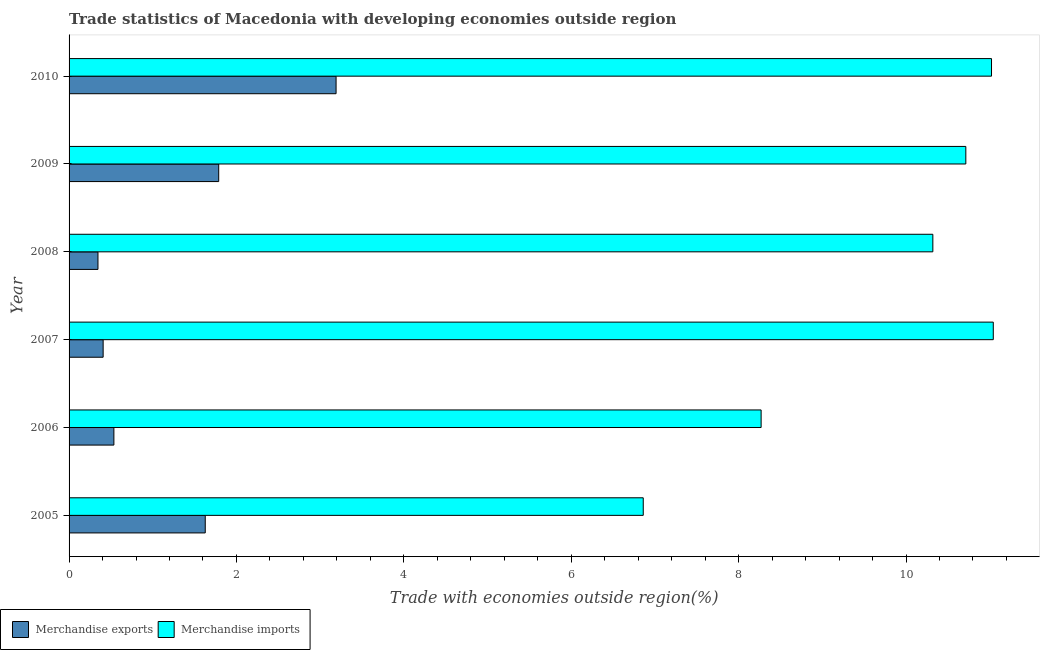How many different coloured bars are there?
Give a very brief answer. 2. How many groups of bars are there?
Your answer should be compact. 6. How many bars are there on the 5th tick from the top?
Ensure brevity in your answer.  2. What is the label of the 2nd group of bars from the top?
Offer a very short reply. 2009. What is the merchandise exports in 2007?
Your answer should be compact. 0.41. Across all years, what is the maximum merchandise imports?
Make the answer very short. 11.04. Across all years, what is the minimum merchandise imports?
Provide a short and direct response. 6.86. In which year was the merchandise imports maximum?
Provide a short and direct response. 2007. In which year was the merchandise exports minimum?
Your answer should be compact. 2008. What is the total merchandise imports in the graph?
Your response must be concise. 58.23. What is the difference between the merchandise imports in 2006 and that in 2008?
Your answer should be very brief. -2.05. What is the difference between the merchandise exports in 2008 and the merchandise imports in 2010?
Make the answer very short. -10.68. What is the average merchandise exports per year?
Ensure brevity in your answer.  1.31. In the year 2005, what is the difference between the merchandise exports and merchandise imports?
Make the answer very short. -5.23. In how many years, is the merchandise imports greater than 10.4 %?
Give a very brief answer. 3. Is the difference between the merchandise exports in 2009 and 2010 greater than the difference between the merchandise imports in 2009 and 2010?
Offer a very short reply. No. What is the difference between the highest and the second highest merchandise imports?
Keep it short and to the point. 0.02. What is the difference between the highest and the lowest merchandise exports?
Your answer should be very brief. 2.84. What does the 2nd bar from the top in 2005 represents?
Your response must be concise. Merchandise exports. How many years are there in the graph?
Make the answer very short. 6. Are the values on the major ticks of X-axis written in scientific E-notation?
Provide a short and direct response. No. Does the graph contain any zero values?
Offer a very short reply. No. Does the graph contain grids?
Keep it short and to the point. No. Where does the legend appear in the graph?
Provide a succinct answer. Bottom left. How many legend labels are there?
Your response must be concise. 2. How are the legend labels stacked?
Ensure brevity in your answer.  Horizontal. What is the title of the graph?
Give a very brief answer. Trade statistics of Macedonia with developing economies outside region. What is the label or title of the X-axis?
Your response must be concise. Trade with economies outside region(%). What is the Trade with economies outside region(%) in Merchandise exports in 2005?
Make the answer very short. 1.63. What is the Trade with economies outside region(%) of Merchandise imports in 2005?
Provide a succinct answer. 6.86. What is the Trade with economies outside region(%) of Merchandise exports in 2006?
Your response must be concise. 0.54. What is the Trade with economies outside region(%) of Merchandise imports in 2006?
Ensure brevity in your answer.  8.27. What is the Trade with economies outside region(%) of Merchandise exports in 2007?
Your answer should be very brief. 0.41. What is the Trade with economies outside region(%) in Merchandise imports in 2007?
Your answer should be very brief. 11.04. What is the Trade with economies outside region(%) of Merchandise exports in 2008?
Provide a succinct answer. 0.35. What is the Trade with economies outside region(%) in Merchandise imports in 2008?
Give a very brief answer. 10.32. What is the Trade with economies outside region(%) of Merchandise exports in 2009?
Offer a terse response. 1.79. What is the Trade with economies outside region(%) in Merchandise imports in 2009?
Your answer should be very brief. 10.71. What is the Trade with economies outside region(%) in Merchandise exports in 2010?
Your response must be concise. 3.19. What is the Trade with economies outside region(%) of Merchandise imports in 2010?
Give a very brief answer. 11.02. Across all years, what is the maximum Trade with economies outside region(%) in Merchandise exports?
Ensure brevity in your answer.  3.19. Across all years, what is the maximum Trade with economies outside region(%) in Merchandise imports?
Your response must be concise. 11.04. Across all years, what is the minimum Trade with economies outside region(%) in Merchandise exports?
Offer a very short reply. 0.35. Across all years, what is the minimum Trade with economies outside region(%) of Merchandise imports?
Offer a terse response. 6.86. What is the total Trade with economies outside region(%) in Merchandise exports in the graph?
Provide a succinct answer. 7.89. What is the total Trade with economies outside region(%) in Merchandise imports in the graph?
Provide a short and direct response. 58.23. What is the difference between the Trade with economies outside region(%) in Merchandise exports in 2005 and that in 2006?
Make the answer very short. 1.09. What is the difference between the Trade with economies outside region(%) of Merchandise imports in 2005 and that in 2006?
Make the answer very short. -1.41. What is the difference between the Trade with economies outside region(%) in Merchandise exports in 2005 and that in 2007?
Provide a short and direct response. 1.22. What is the difference between the Trade with economies outside region(%) in Merchandise imports in 2005 and that in 2007?
Make the answer very short. -4.18. What is the difference between the Trade with economies outside region(%) in Merchandise exports in 2005 and that in 2008?
Offer a terse response. 1.28. What is the difference between the Trade with economies outside region(%) of Merchandise imports in 2005 and that in 2008?
Provide a short and direct response. -3.46. What is the difference between the Trade with economies outside region(%) in Merchandise exports in 2005 and that in 2009?
Offer a terse response. -0.16. What is the difference between the Trade with economies outside region(%) in Merchandise imports in 2005 and that in 2009?
Offer a terse response. -3.85. What is the difference between the Trade with economies outside region(%) of Merchandise exports in 2005 and that in 2010?
Your answer should be very brief. -1.56. What is the difference between the Trade with economies outside region(%) in Merchandise imports in 2005 and that in 2010?
Keep it short and to the point. -4.16. What is the difference between the Trade with economies outside region(%) in Merchandise exports in 2006 and that in 2007?
Give a very brief answer. 0.13. What is the difference between the Trade with economies outside region(%) in Merchandise imports in 2006 and that in 2007?
Make the answer very short. -2.77. What is the difference between the Trade with economies outside region(%) of Merchandise exports in 2006 and that in 2008?
Ensure brevity in your answer.  0.19. What is the difference between the Trade with economies outside region(%) of Merchandise imports in 2006 and that in 2008?
Keep it short and to the point. -2.05. What is the difference between the Trade with economies outside region(%) in Merchandise exports in 2006 and that in 2009?
Your answer should be compact. -1.25. What is the difference between the Trade with economies outside region(%) in Merchandise imports in 2006 and that in 2009?
Offer a terse response. -2.45. What is the difference between the Trade with economies outside region(%) of Merchandise exports in 2006 and that in 2010?
Your response must be concise. -2.65. What is the difference between the Trade with economies outside region(%) in Merchandise imports in 2006 and that in 2010?
Offer a terse response. -2.75. What is the difference between the Trade with economies outside region(%) of Merchandise exports in 2007 and that in 2008?
Provide a succinct answer. 0.06. What is the difference between the Trade with economies outside region(%) in Merchandise imports in 2007 and that in 2008?
Your answer should be very brief. 0.72. What is the difference between the Trade with economies outside region(%) of Merchandise exports in 2007 and that in 2009?
Provide a short and direct response. -1.38. What is the difference between the Trade with economies outside region(%) of Merchandise imports in 2007 and that in 2009?
Give a very brief answer. 0.33. What is the difference between the Trade with economies outside region(%) in Merchandise exports in 2007 and that in 2010?
Offer a terse response. -2.78. What is the difference between the Trade with economies outside region(%) of Merchandise imports in 2007 and that in 2010?
Make the answer very short. 0.02. What is the difference between the Trade with economies outside region(%) of Merchandise exports in 2008 and that in 2009?
Your response must be concise. -1.44. What is the difference between the Trade with economies outside region(%) of Merchandise imports in 2008 and that in 2009?
Ensure brevity in your answer.  -0.39. What is the difference between the Trade with economies outside region(%) in Merchandise exports in 2008 and that in 2010?
Keep it short and to the point. -2.84. What is the difference between the Trade with economies outside region(%) in Merchandise imports in 2008 and that in 2010?
Give a very brief answer. -0.7. What is the difference between the Trade with economies outside region(%) in Merchandise exports in 2009 and that in 2010?
Offer a terse response. -1.4. What is the difference between the Trade with economies outside region(%) in Merchandise imports in 2009 and that in 2010?
Your response must be concise. -0.31. What is the difference between the Trade with economies outside region(%) of Merchandise exports in 2005 and the Trade with economies outside region(%) of Merchandise imports in 2006?
Your answer should be very brief. -6.64. What is the difference between the Trade with economies outside region(%) in Merchandise exports in 2005 and the Trade with economies outside region(%) in Merchandise imports in 2007?
Keep it short and to the point. -9.42. What is the difference between the Trade with economies outside region(%) in Merchandise exports in 2005 and the Trade with economies outside region(%) in Merchandise imports in 2008?
Offer a terse response. -8.69. What is the difference between the Trade with economies outside region(%) of Merchandise exports in 2005 and the Trade with economies outside region(%) of Merchandise imports in 2009?
Provide a succinct answer. -9.09. What is the difference between the Trade with economies outside region(%) in Merchandise exports in 2005 and the Trade with economies outside region(%) in Merchandise imports in 2010?
Make the answer very short. -9.39. What is the difference between the Trade with economies outside region(%) of Merchandise exports in 2006 and the Trade with economies outside region(%) of Merchandise imports in 2007?
Give a very brief answer. -10.51. What is the difference between the Trade with economies outside region(%) in Merchandise exports in 2006 and the Trade with economies outside region(%) in Merchandise imports in 2008?
Provide a short and direct response. -9.79. What is the difference between the Trade with economies outside region(%) in Merchandise exports in 2006 and the Trade with economies outside region(%) in Merchandise imports in 2009?
Provide a short and direct response. -10.18. What is the difference between the Trade with economies outside region(%) of Merchandise exports in 2006 and the Trade with economies outside region(%) of Merchandise imports in 2010?
Ensure brevity in your answer.  -10.49. What is the difference between the Trade with economies outside region(%) in Merchandise exports in 2007 and the Trade with economies outside region(%) in Merchandise imports in 2008?
Provide a succinct answer. -9.91. What is the difference between the Trade with economies outside region(%) in Merchandise exports in 2007 and the Trade with economies outside region(%) in Merchandise imports in 2009?
Ensure brevity in your answer.  -10.31. What is the difference between the Trade with economies outside region(%) of Merchandise exports in 2007 and the Trade with economies outside region(%) of Merchandise imports in 2010?
Ensure brevity in your answer.  -10.61. What is the difference between the Trade with economies outside region(%) of Merchandise exports in 2008 and the Trade with economies outside region(%) of Merchandise imports in 2009?
Make the answer very short. -10.37. What is the difference between the Trade with economies outside region(%) of Merchandise exports in 2008 and the Trade with economies outside region(%) of Merchandise imports in 2010?
Your answer should be compact. -10.68. What is the difference between the Trade with economies outside region(%) of Merchandise exports in 2009 and the Trade with economies outside region(%) of Merchandise imports in 2010?
Offer a terse response. -9.23. What is the average Trade with economies outside region(%) of Merchandise exports per year?
Ensure brevity in your answer.  1.32. What is the average Trade with economies outside region(%) of Merchandise imports per year?
Ensure brevity in your answer.  9.7. In the year 2005, what is the difference between the Trade with economies outside region(%) in Merchandise exports and Trade with economies outside region(%) in Merchandise imports?
Give a very brief answer. -5.23. In the year 2006, what is the difference between the Trade with economies outside region(%) in Merchandise exports and Trade with economies outside region(%) in Merchandise imports?
Make the answer very short. -7.73. In the year 2007, what is the difference between the Trade with economies outside region(%) in Merchandise exports and Trade with economies outside region(%) in Merchandise imports?
Offer a very short reply. -10.64. In the year 2008, what is the difference between the Trade with economies outside region(%) of Merchandise exports and Trade with economies outside region(%) of Merchandise imports?
Ensure brevity in your answer.  -9.98. In the year 2009, what is the difference between the Trade with economies outside region(%) in Merchandise exports and Trade with economies outside region(%) in Merchandise imports?
Provide a short and direct response. -8.93. In the year 2010, what is the difference between the Trade with economies outside region(%) in Merchandise exports and Trade with economies outside region(%) in Merchandise imports?
Provide a short and direct response. -7.83. What is the ratio of the Trade with economies outside region(%) in Merchandise exports in 2005 to that in 2006?
Make the answer very short. 3.04. What is the ratio of the Trade with economies outside region(%) of Merchandise imports in 2005 to that in 2006?
Provide a succinct answer. 0.83. What is the ratio of the Trade with economies outside region(%) of Merchandise exports in 2005 to that in 2007?
Your response must be concise. 4. What is the ratio of the Trade with economies outside region(%) of Merchandise imports in 2005 to that in 2007?
Your answer should be very brief. 0.62. What is the ratio of the Trade with economies outside region(%) in Merchandise exports in 2005 to that in 2008?
Give a very brief answer. 4.71. What is the ratio of the Trade with economies outside region(%) in Merchandise imports in 2005 to that in 2008?
Ensure brevity in your answer.  0.66. What is the ratio of the Trade with economies outside region(%) of Merchandise exports in 2005 to that in 2009?
Ensure brevity in your answer.  0.91. What is the ratio of the Trade with economies outside region(%) in Merchandise imports in 2005 to that in 2009?
Your answer should be compact. 0.64. What is the ratio of the Trade with economies outside region(%) in Merchandise exports in 2005 to that in 2010?
Your answer should be compact. 0.51. What is the ratio of the Trade with economies outside region(%) in Merchandise imports in 2005 to that in 2010?
Offer a very short reply. 0.62. What is the ratio of the Trade with economies outside region(%) of Merchandise exports in 2006 to that in 2007?
Your response must be concise. 1.32. What is the ratio of the Trade with economies outside region(%) of Merchandise imports in 2006 to that in 2007?
Ensure brevity in your answer.  0.75. What is the ratio of the Trade with economies outside region(%) in Merchandise exports in 2006 to that in 2008?
Your answer should be very brief. 1.55. What is the ratio of the Trade with economies outside region(%) of Merchandise imports in 2006 to that in 2008?
Your answer should be compact. 0.8. What is the ratio of the Trade with economies outside region(%) in Merchandise exports in 2006 to that in 2009?
Keep it short and to the point. 0.3. What is the ratio of the Trade with economies outside region(%) in Merchandise imports in 2006 to that in 2009?
Your answer should be very brief. 0.77. What is the ratio of the Trade with economies outside region(%) in Merchandise exports in 2006 to that in 2010?
Your answer should be very brief. 0.17. What is the ratio of the Trade with economies outside region(%) of Merchandise imports in 2006 to that in 2010?
Provide a short and direct response. 0.75. What is the ratio of the Trade with economies outside region(%) in Merchandise exports in 2007 to that in 2008?
Provide a succinct answer. 1.18. What is the ratio of the Trade with economies outside region(%) in Merchandise imports in 2007 to that in 2008?
Offer a terse response. 1.07. What is the ratio of the Trade with economies outside region(%) in Merchandise exports in 2007 to that in 2009?
Your response must be concise. 0.23. What is the ratio of the Trade with economies outside region(%) in Merchandise imports in 2007 to that in 2009?
Give a very brief answer. 1.03. What is the ratio of the Trade with economies outside region(%) in Merchandise exports in 2007 to that in 2010?
Your answer should be compact. 0.13. What is the ratio of the Trade with economies outside region(%) of Merchandise imports in 2007 to that in 2010?
Make the answer very short. 1. What is the ratio of the Trade with economies outside region(%) of Merchandise exports in 2008 to that in 2009?
Offer a terse response. 0.19. What is the ratio of the Trade with economies outside region(%) of Merchandise imports in 2008 to that in 2009?
Your answer should be very brief. 0.96. What is the ratio of the Trade with economies outside region(%) in Merchandise exports in 2008 to that in 2010?
Give a very brief answer. 0.11. What is the ratio of the Trade with economies outside region(%) of Merchandise imports in 2008 to that in 2010?
Keep it short and to the point. 0.94. What is the ratio of the Trade with economies outside region(%) of Merchandise exports in 2009 to that in 2010?
Give a very brief answer. 0.56. What is the ratio of the Trade with economies outside region(%) in Merchandise imports in 2009 to that in 2010?
Keep it short and to the point. 0.97. What is the difference between the highest and the second highest Trade with economies outside region(%) in Merchandise exports?
Provide a short and direct response. 1.4. What is the difference between the highest and the second highest Trade with economies outside region(%) of Merchandise imports?
Offer a very short reply. 0.02. What is the difference between the highest and the lowest Trade with economies outside region(%) in Merchandise exports?
Give a very brief answer. 2.84. What is the difference between the highest and the lowest Trade with economies outside region(%) in Merchandise imports?
Keep it short and to the point. 4.18. 